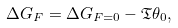<formula> <loc_0><loc_0><loc_500><loc_500>\Delta G _ { F } = \Delta G _ { F = 0 } - \mathfrak { T } \theta _ { 0 } ,</formula> 